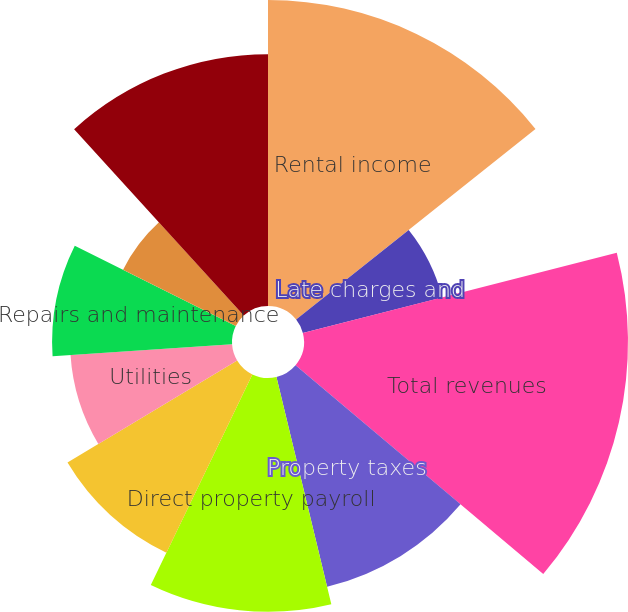Convert chart. <chart><loc_0><loc_0><loc_500><loc_500><pie_chart><fcel>Rental income<fcel>Late charges and<fcel>Total revenues<fcel>Property taxes<fcel>Direct property payroll<fcel>Advertising and promotion<fcel>Utilities<fcel>Repairs and maintenance<fcel>Property insurance<fcel>Other costs of management<nl><fcel>14.29%<fcel>6.72%<fcel>15.13%<fcel>10.08%<fcel>10.92%<fcel>9.24%<fcel>7.56%<fcel>8.4%<fcel>5.88%<fcel>11.76%<nl></chart> 